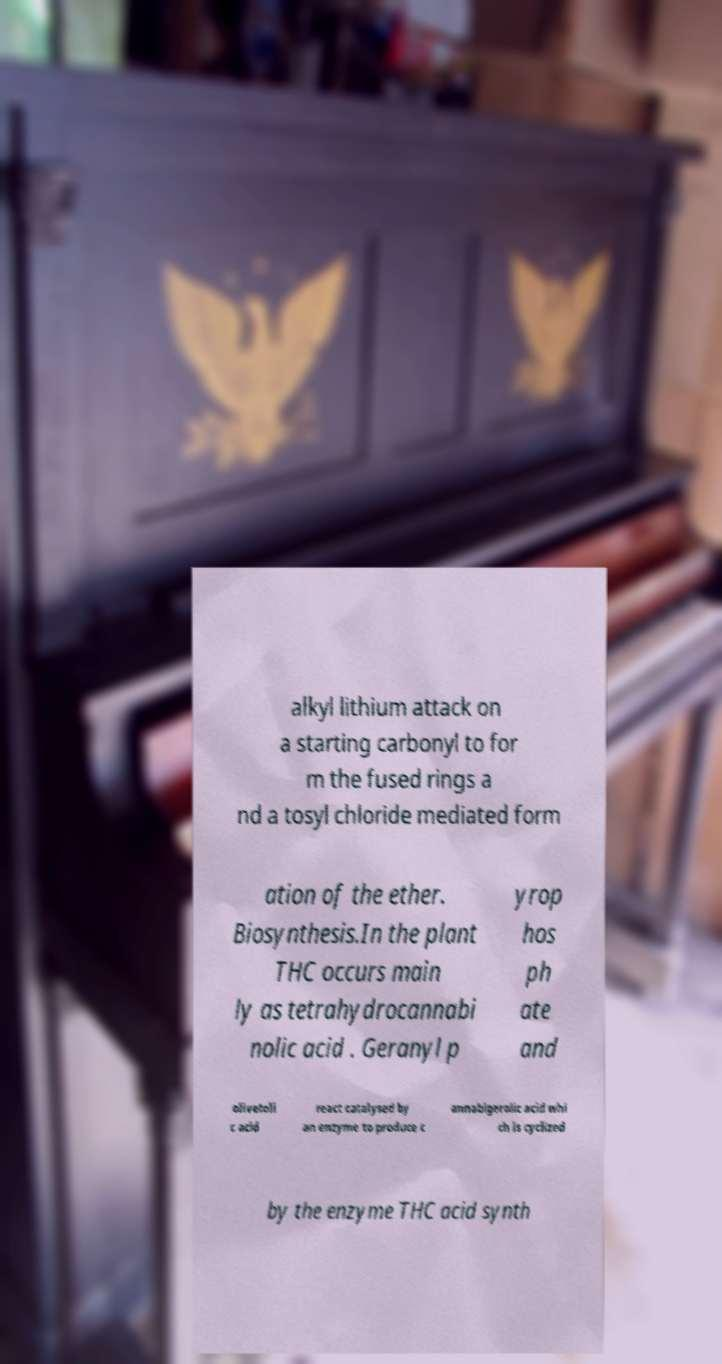Can you read and provide the text displayed in the image?This photo seems to have some interesting text. Can you extract and type it out for me? alkyl lithium attack on a starting carbonyl to for m the fused rings a nd a tosyl chloride mediated form ation of the ether. Biosynthesis.In the plant THC occurs main ly as tetrahydrocannabi nolic acid . Geranyl p yrop hos ph ate and olivetoli c acid react catalysed by an enzyme to produce c annabigerolic acid whi ch is cyclized by the enzyme THC acid synth 